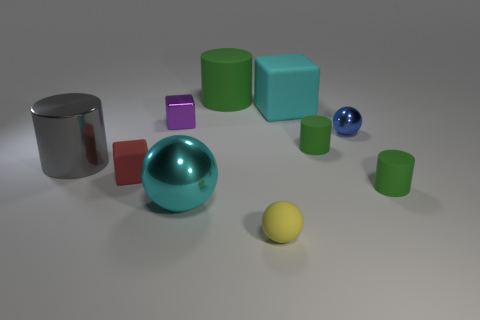Is the big rubber cube the same color as the large sphere?
Provide a succinct answer. Yes. Is there a block that has the same color as the large metal sphere?
Give a very brief answer. Yes. Is there a red block that has the same material as the large green cylinder?
Ensure brevity in your answer.  Yes. What is the shape of the large object that is in front of the big cyan cube and right of the tiny purple metallic thing?
Your answer should be compact. Sphere. How many large objects are either blue metallic spheres or red rubber cubes?
Make the answer very short. 0. What material is the cyan cube?
Offer a terse response. Rubber. What number of other objects are there of the same shape as the small blue object?
Provide a short and direct response. 2. What is the size of the cyan sphere?
Make the answer very short. Large. There is a metallic thing that is on the left side of the blue shiny thing and on the right side of the small purple metal thing; how big is it?
Offer a terse response. Large. The metal thing that is right of the small yellow matte ball has what shape?
Keep it short and to the point. Sphere. 